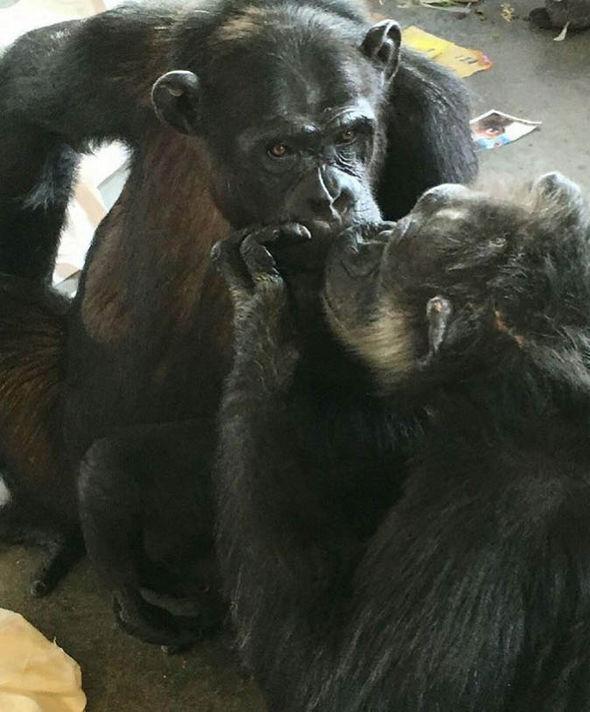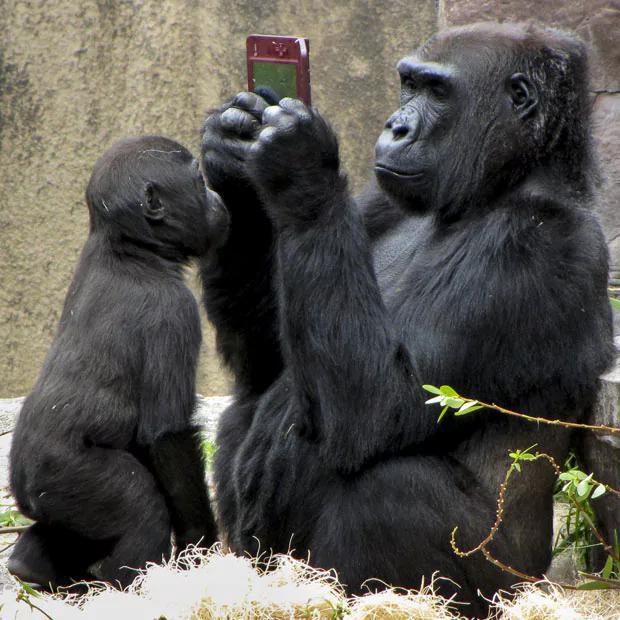The first image is the image on the left, the second image is the image on the right. Assess this claim about the two images: "Both images show a pair of chimps with their mouths very close together.". Correct or not? Answer yes or no. No. The first image is the image on the left, the second image is the image on the right. Analyze the images presented: Is the assertion "In one of the pictures, two primates kissing each other on the lips, and in the other, a baby primate is next to an adult." valid? Answer yes or no. Yes. 